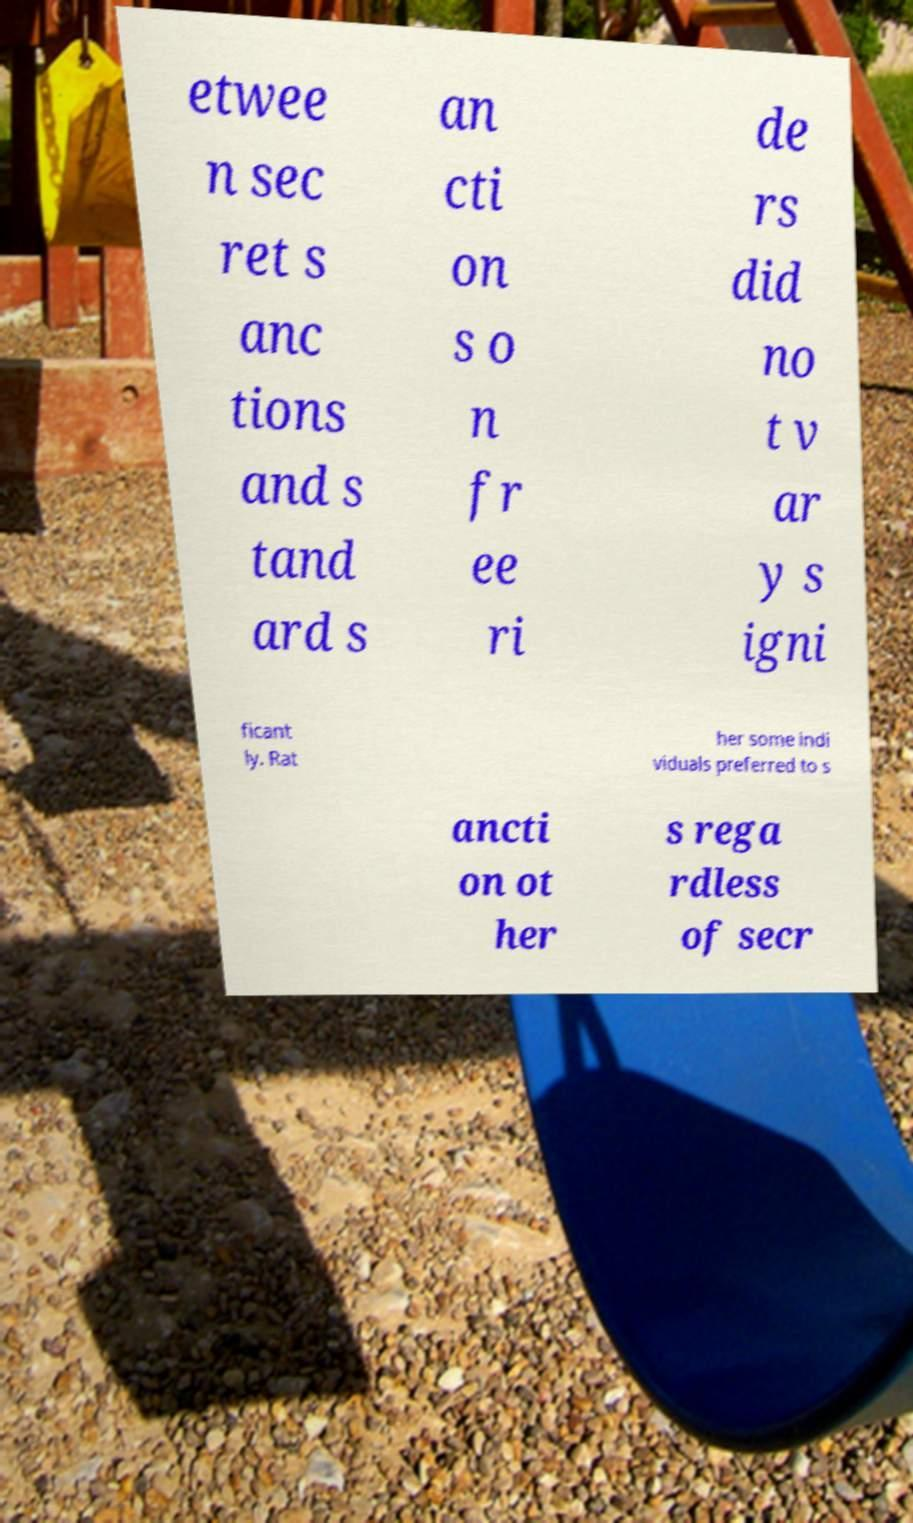Please identify and transcribe the text found in this image. etwee n sec ret s anc tions and s tand ard s an cti on s o n fr ee ri de rs did no t v ar y s igni ficant ly. Rat her some indi viduals preferred to s ancti on ot her s rega rdless of secr 